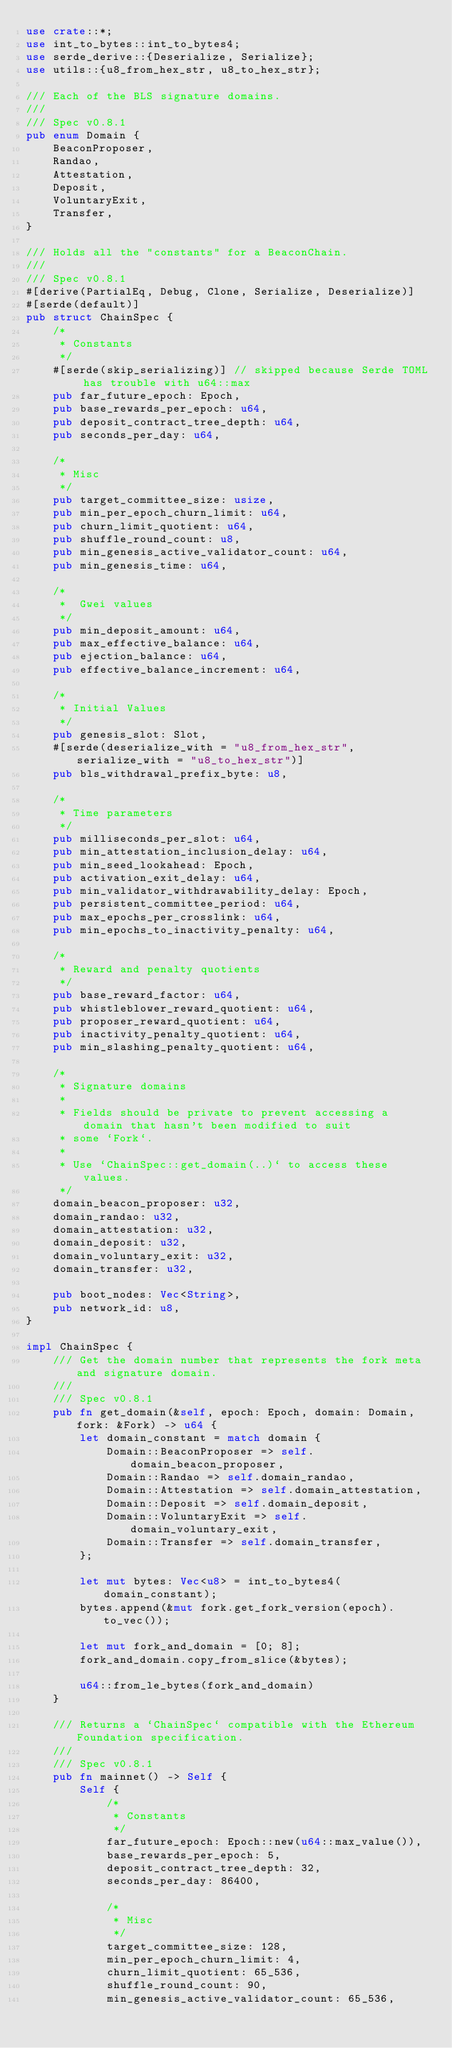<code> <loc_0><loc_0><loc_500><loc_500><_Rust_>use crate::*;
use int_to_bytes::int_to_bytes4;
use serde_derive::{Deserialize, Serialize};
use utils::{u8_from_hex_str, u8_to_hex_str};

/// Each of the BLS signature domains.
///
/// Spec v0.8.1
pub enum Domain {
    BeaconProposer,
    Randao,
    Attestation,
    Deposit,
    VoluntaryExit,
    Transfer,
}

/// Holds all the "constants" for a BeaconChain.
///
/// Spec v0.8.1
#[derive(PartialEq, Debug, Clone, Serialize, Deserialize)]
#[serde(default)]
pub struct ChainSpec {
    /*
     * Constants
     */
    #[serde(skip_serializing)] // skipped because Serde TOML has trouble with u64::max
    pub far_future_epoch: Epoch,
    pub base_rewards_per_epoch: u64,
    pub deposit_contract_tree_depth: u64,
    pub seconds_per_day: u64,

    /*
     * Misc
     */
    pub target_committee_size: usize,
    pub min_per_epoch_churn_limit: u64,
    pub churn_limit_quotient: u64,
    pub shuffle_round_count: u8,
    pub min_genesis_active_validator_count: u64,
    pub min_genesis_time: u64,

    /*
     *  Gwei values
     */
    pub min_deposit_amount: u64,
    pub max_effective_balance: u64,
    pub ejection_balance: u64,
    pub effective_balance_increment: u64,

    /*
     * Initial Values
     */
    pub genesis_slot: Slot,
    #[serde(deserialize_with = "u8_from_hex_str", serialize_with = "u8_to_hex_str")]
    pub bls_withdrawal_prefix_byte: u8,

    /*
     * Time parameters
     */
    pub milliseconds_per_slot: u64,
    pub min_attestation_inclusion_delay: u64,
    pub min_seed_lookahead: Epoch,
    pub activation_exit_delay: u64,
    pub min_validator_withdrawability_delay: Epoch,
    pub persistent_committee_period: u64,
    pub max_epochs_per_crosslink: u64,
    pub min_epochs_to_inactivity_penalty: u64,

    /*
     * Reward and penalty quotients
     */
    pub base_reward_factor: u64,
    pub whistleblower_reward_quotient: u64,
    pub proposer_reward_quotient: u64,
    pub inactivity_penalty_quotient: u64,
    pub min_slashing_penalty_quotient: u64,

    /*
     * Signature domains
     *
     * Fields should be private to prevent accessing a domain that hasn't been modified to suit
     * some `Fork`.
     *
     * Use `ChainSpec::get_domain(..)` to access these values.
     */
    domain_beacon_proposer: u32,
    domain_randao: u32,
    domain_attestation: u32,
    domain_deposit: u32,
    domain_voluntary_exit: u32,
    domain_transfer: u32,

    pub boot_nodes: Vec<String>,
    pub network_id: u8,
}

impl ChainSpec {
    /// Get the domain number that represents the fork meta and signature domain.
    ///
    /// Spec v0.8.1
    pub fn get_domain(&self, epoch: Epoch, domain: Domain, fork: &Fork) -> u64 {
        let domain_constant = match domain {
            Domain::BeaconProposer => self.domain_beacon_proposer,
            Domain::Randao => self.domain_randao,
            Domain::Attestation => self.domain_attestation,
            Domain::Deposit => self.domain_deposit,
            Domain::VoluntaryExit => self.domain_voluntary_exit,
            Domain::Transfer => self.domain_transfer,
        };

        let mut bytes: Vec<u8> = int_to_bytes4(domain_constant);
        bytes.append(&mut fork.get_fork_version(epoch).to_vec());

        let mut fork_and_domain = [0; 8];
        fork_and_domain.copy_from_slice(&bytes);

        u64::from_le_bytes(fork_and_domain)
    }

    /// Returns a `ChainSpec` compatible with the Ethereum Foundation specification.
    ///
    /// Spec v0.8.1
    pub fn mainnet() -> Self {
        Self {
            /*
             * Constants
             */
            far_future_epoch: Epoch::new(u64::max_value()),
            base_rewards_per_epoch: 5,
            deposit_contract_tree_depth: 32,
            seconds_per_day: 86400,

            /*
             * Misc
             */
            target_committee_size: 128,
            min_per_epoch_churn_limit: 4,
            churn_limit_quotient: 65_536,
            shuffle_round_count: 90,
            min_genesis_active_validator_count: 65_536,</code> 